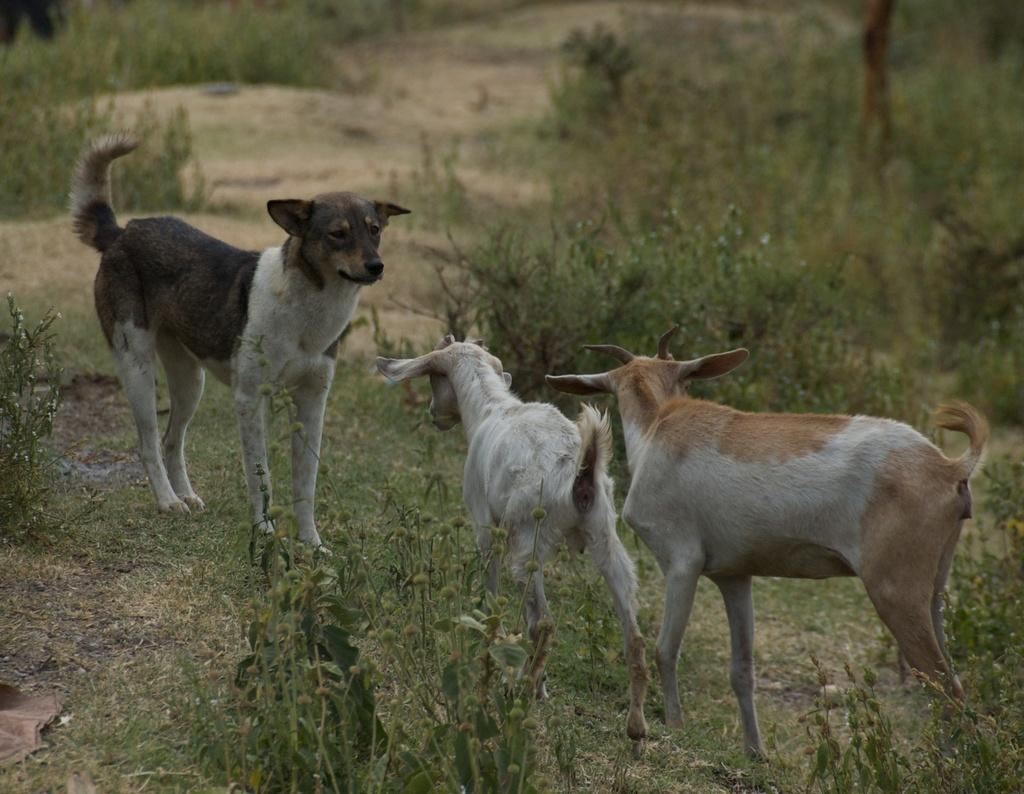What type of animal can be seen in the image? There is a dog in the image. How many goats are present in the image? There are two goats in the image. Where are the dog and goats standing? The dog and goats are standing on the grass. What type of vegetation is visible in the image? There are trees visible in the image. What type of laborer is working in the image? There is no laborer present in the image; it features a dog and two goats standing on the grass. Can you tell me what color the mittens are in the image? There are no mittens present in the image. 